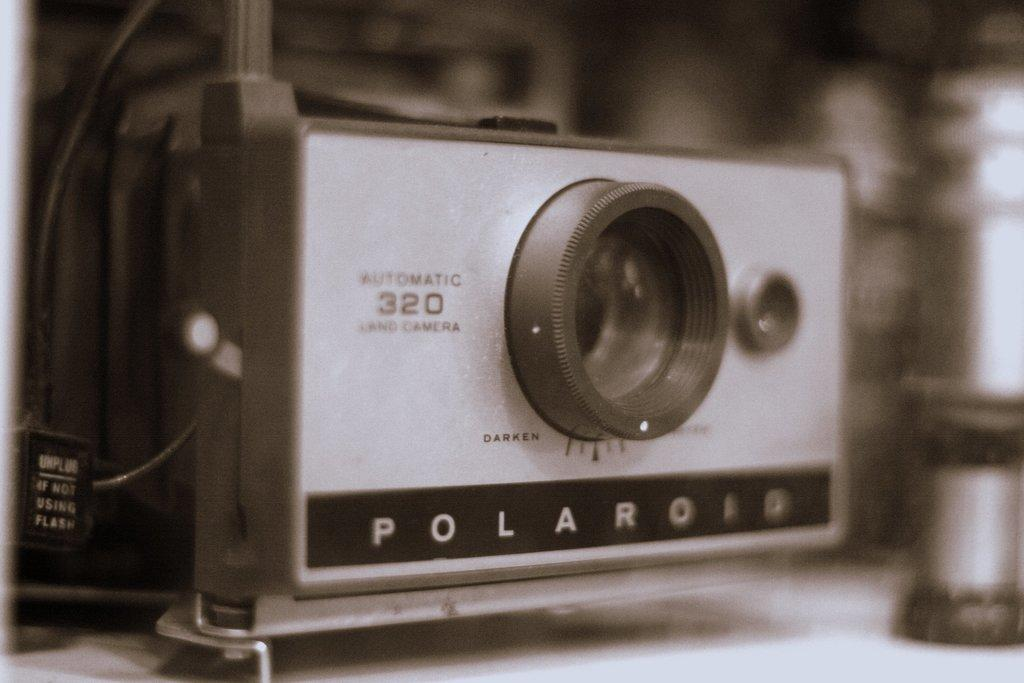What is the main object in the image? There is a camera with a lens in the image. What can be seen on the left side of the image? There are wires on the left side of the image. How would you describe the background of the image? The background of the image has a blurred view. What are the boys discussing in the image? There are no boys present in the image, so it is not possible to determine what they might be discussing. 